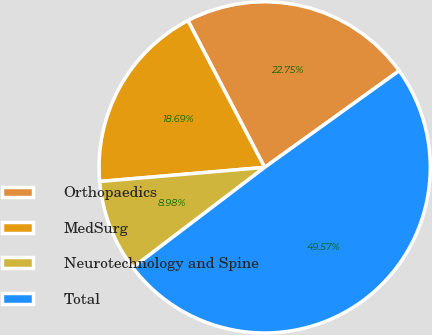Convert chart. <chart><loc_0><loc_0><loc_500><loc_500><pie_chart><fcel>Orthopaedics<fcel>MedSurg<fcel>Neurotechnology and Spine<fcel>Total<nl><fcel>22.75%<fcel>18.69%<fcel>8.98%<fcel>49.57%<nl></chart> 